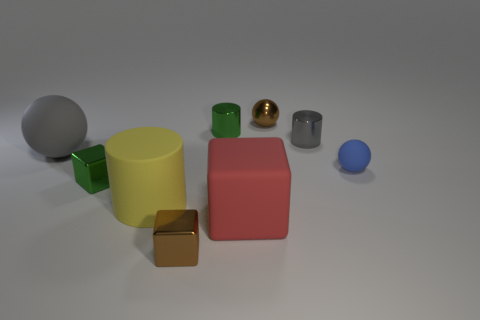Subtract all gray cubes. Subtract all brown spheres. How many cubes are left? 3 Add 1 big rubber things. How many objects exist? 10 Subtract all balls. How many objects are left? 6 Subtract 1 brown cubes. How many objects are left? 8 Subtract all big things. Subtract all small green objects. How many objects are left? 4 Add 7 spheres. How many spheres are left? 10 Add 1 small yellow rubber blocks. How many small yellow rubber blocks exist? 1 